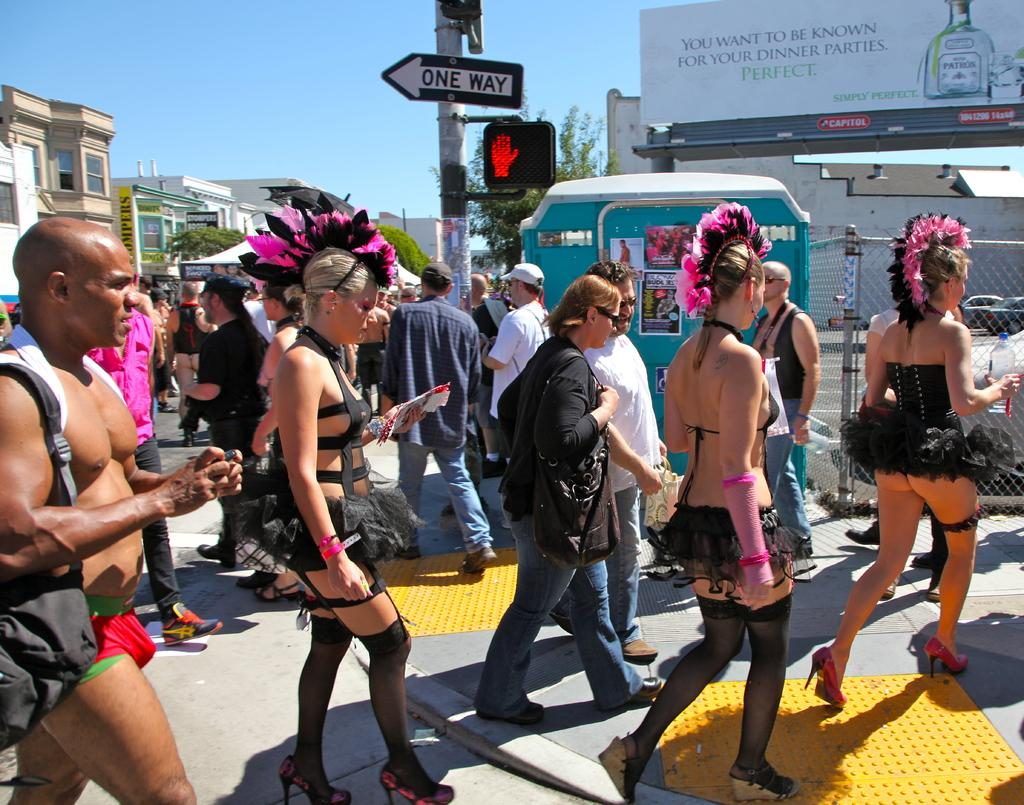What are the people in the image wearing? The people in the image are wearing costumes. What can be seen in the middle of the image? There is a pole in the image. What is on the right side of the image? There is a mesh on the right side of the image. What type of vehicles are visible in the image? There are cars in the image. What can be seen in the background of the image? There are boards, trees, buildings, and the sky visible in the background of the image. What type of health advice can be seen on the boards in the background of the image? There is no health advice visible on the boards in the background of the image. How does the sense of smell play a role in the image? The sense of smell does not play a role in the image, as there are no scents or smells mentioned or depicted. 